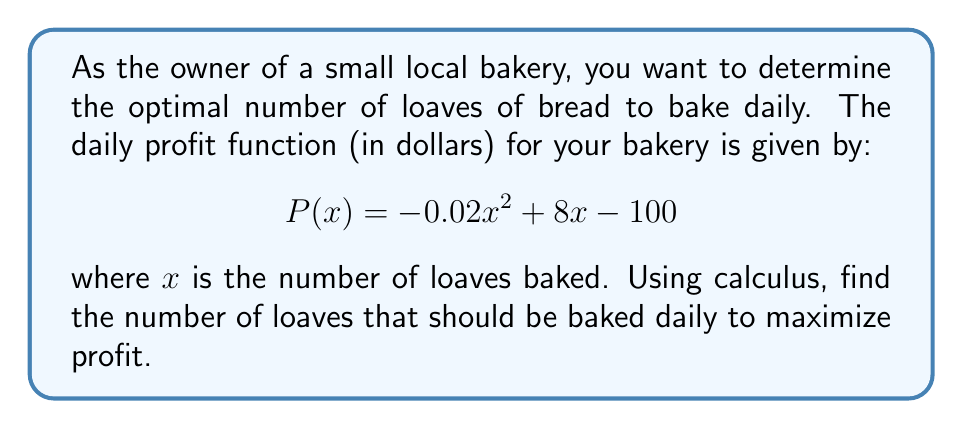Teach me how to tackle this problem. To find the optimal number of loaves to bake, we need to maximize the profit function $P(x)$. This can be done by finding the critical point where the derivative of $P(x)$ equals zero.

Step 1: Find the derivative of $P(x)$
$$P'(x) = \frac{d}{dx}(-0.02x^2 + 8x - 100)$$
$$P'(x) = -0.04x + 8$$

Step 2: Set the derivative equal to zero and solve for x
$$-0.04x + 8 = 0$$
$$-0.04x = -8$$
$$x = \frac{-8}{-0.04} = 200$$

Step 3: Verify that this critical point is a maximum
We can confirm this is a maximum by checking the second derivative:
$$P''(x) = -0.04$$
Since $P''(x)$ is negative, the critical point is indeed a maximum.

Step 4: Check the endpoints (if applicable)
In this case, there are no relevant endpoints to check, as the number of loaves can theoretically be any non-negative real number.

Therefore, the profit is maximized when 200 loaves are baked daily.

Step 5: Calculate the maximum profit
$$P(200) = -0.02(200)^2 + 8(200) - 100$$
$$= -800 + 1600 - 100 = 700$$

The maximum daily profit is $700.
Answer: The optimal number of loaves to bake daily is 200, which results in a maximum profit of $700. 